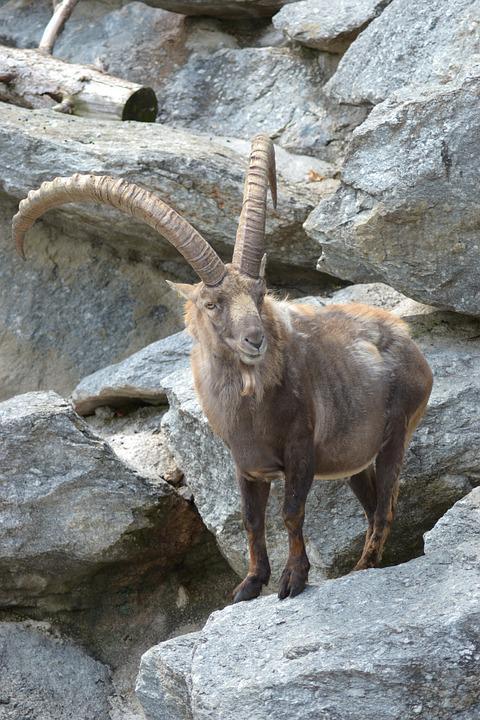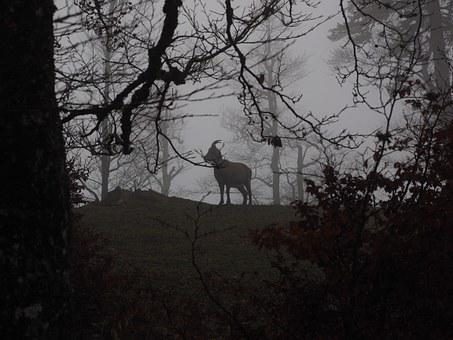The first image is the image on the left, the second image is the image on the right. Evaluate the accuracy of this statement regarding the images: "Some of the animals are butting heads.". Is it true? Answer yes or no. No. 